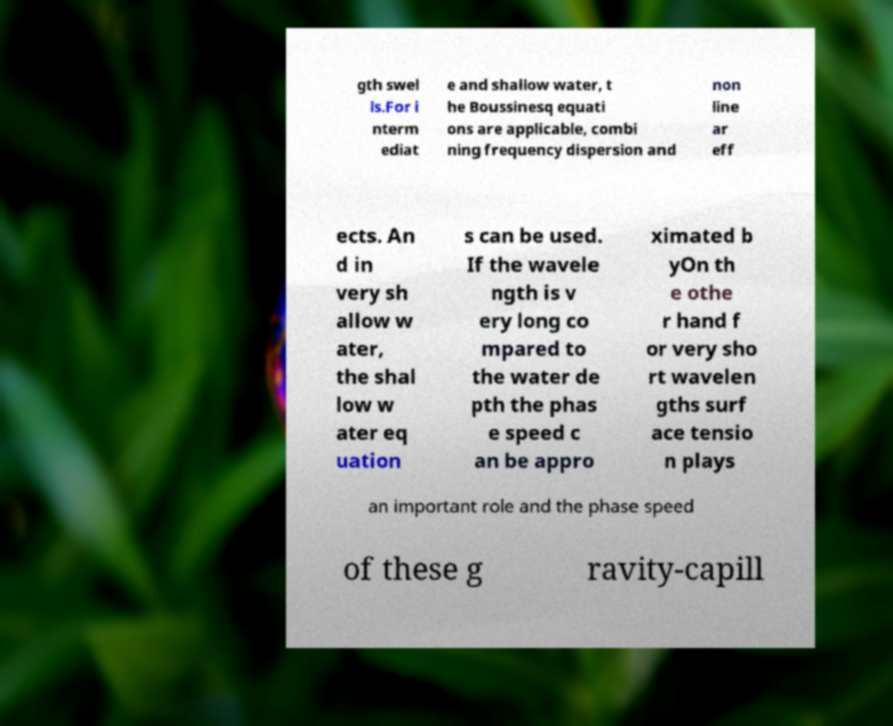Could you extract and type out the text from this image? gth swel ls.For i nterm ediat e and shallow water, t he Boussinesq equati ons are applicable, combi ning frequency dispersion and non line ar eff ects. An d in very sh allow w ater, the shal low w ater eq uation s can be used. If the wavele ngth is v ery long co mpared to the water de pth the phas e speed c an be appro ximated b yOn th e othe r hand f or very sho rt wavelen gths surf ace tensio n plays an important role and the phase speed of these g ravity-capill 